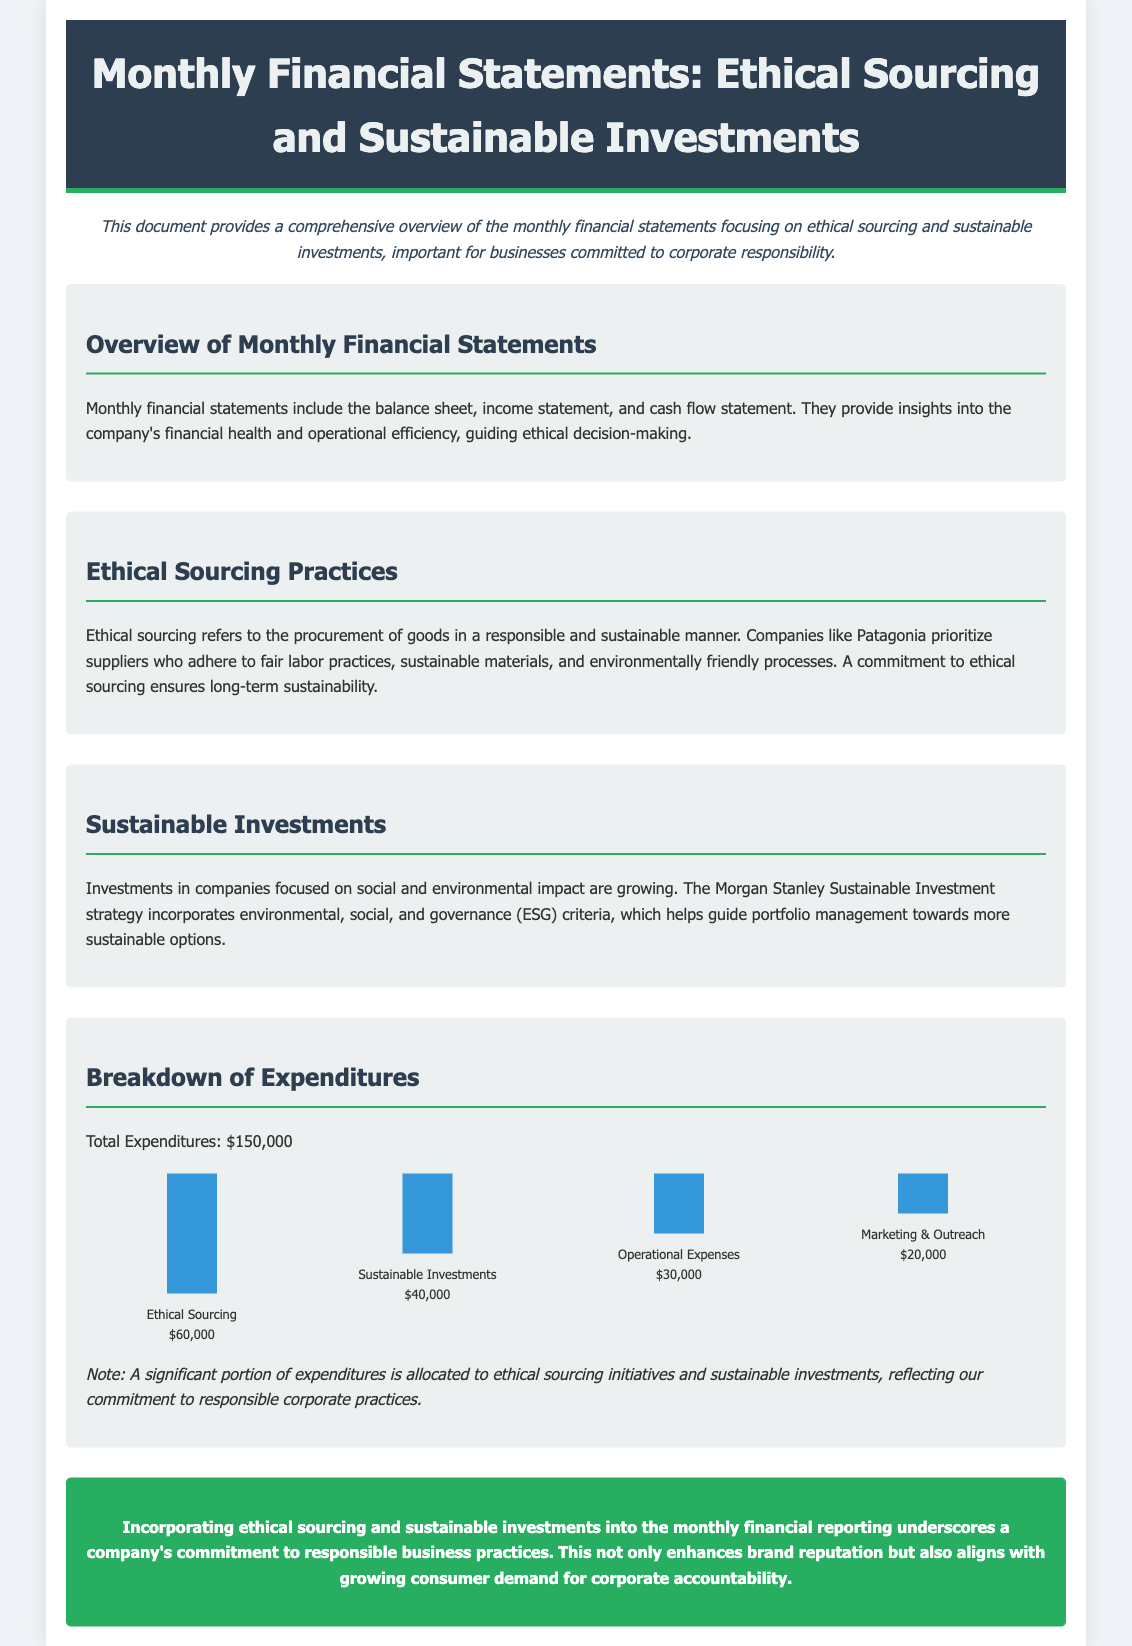what is the total expenditure? The total expenditure is explicitly stated in the document under the breakdown of expenditures.
Answer: $150,000 how much is allocated to ethical sourcing? The document provides a specific amount allocated to ethical sourcing in the expenditure breakdown.
Answer: $60,000 what is the percentage of expenditures on sustainable investments relative to total expenditures? The sustainable investments amount is given, and the total is known, allowing for a calculation of the percentage.
Answer: 26.67% how many sections are in the document? By counting the defined sections in the document, we can determine the total number of sections.
Answer: 4 what color is the header background? The document visually describes the header background color.
Answer: Dark blue which company is mentioned as an example of ethical sourcing? The document specifically names a company that exemplifies ethical sourcing practices.
Answer: Patagonia what is the focus of the sustainable investments strategy mentioned? The document explains the focus or criteria for sustainable investments referenced.
Answer: ESG criteria what is included in monthly financial statements? The document lists the components of monthly financial statements that provide financial insights.
Answer: Balance sheet, income statement, cash flow statement what nature of expenses does marketing & outreach represent? The document categorizes marketing & outreach under specific types of expenses outlined in the expenditures.
Answer: Operational Expenses 